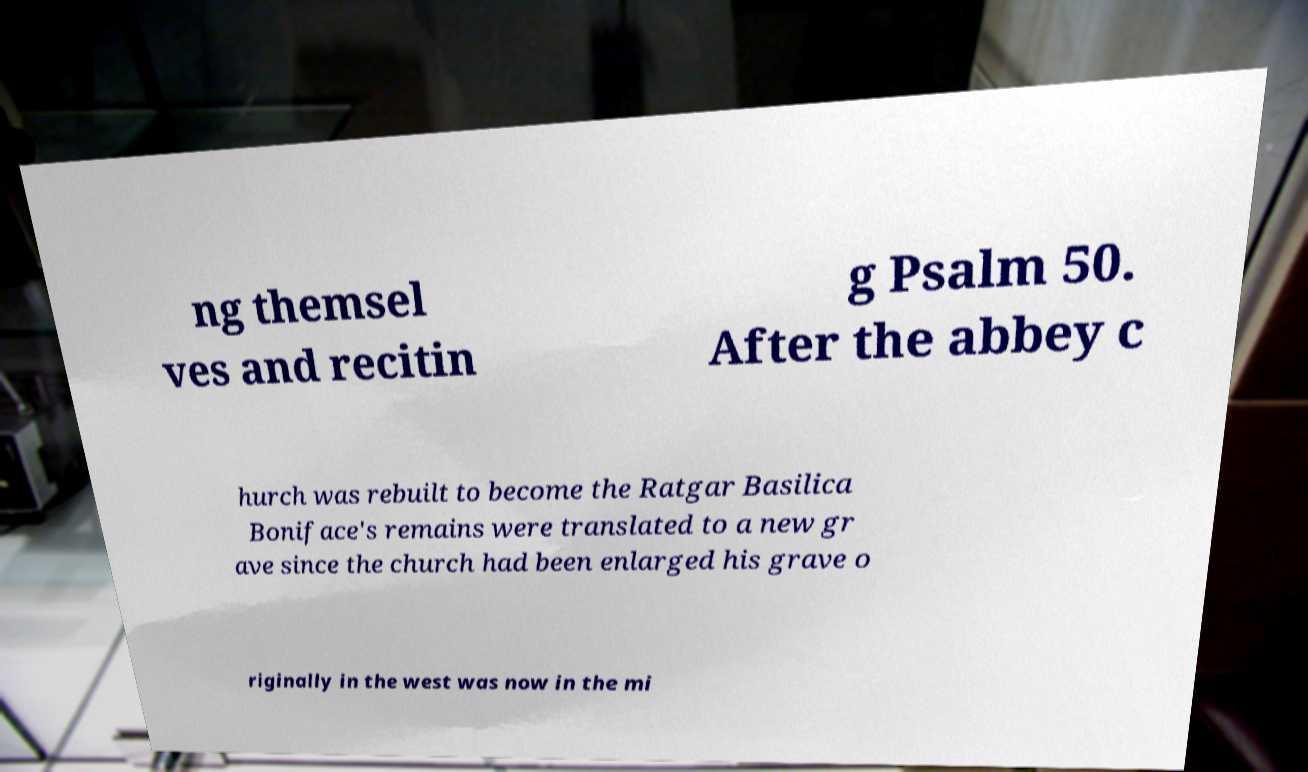What messages or text are displayed in this image? I need them in a readable, typed format. ng themsel ves and recitin g Psalm 50. After the abbey c hurch was rebuilt to become the Ratgar Basilica Boniface's remains were translated to a new gr ave since the church had been enlarged his grave o riginally in the west was now in the mi 